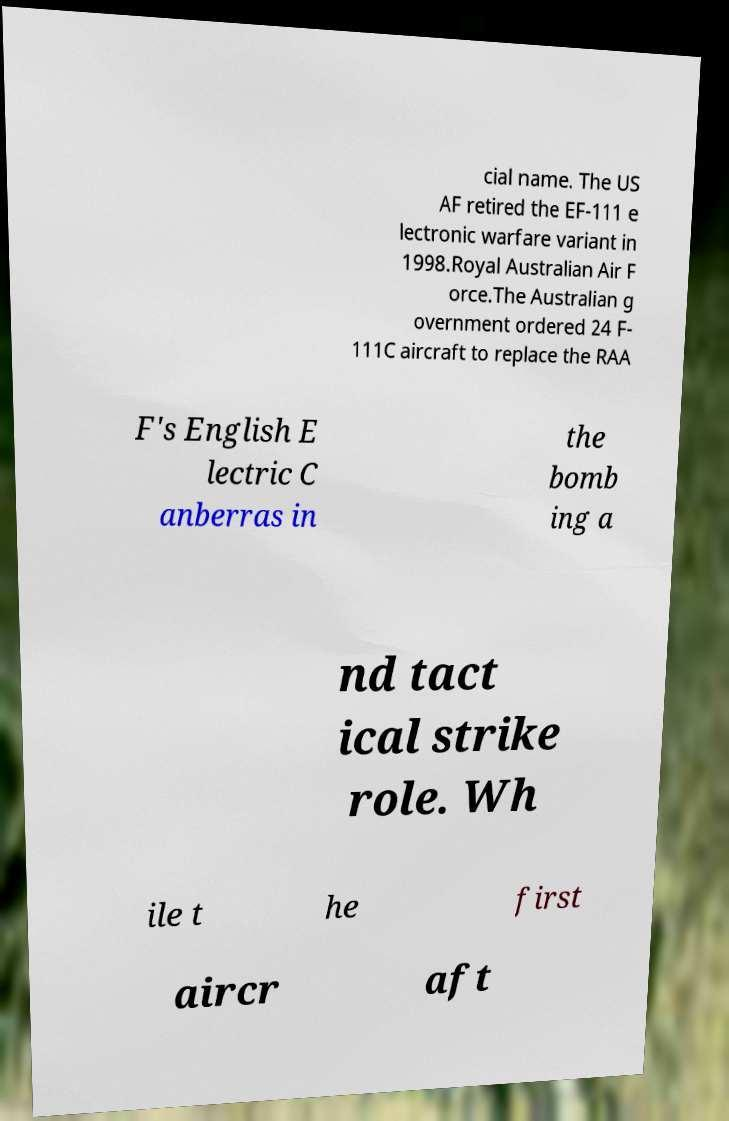There's text embedded in this image that I need extracted. Can you transcribe it verbatim? cial name. The US AF retired the EF-111 e lectronic warfare variant in 1998.Royal Australian Air F orce.The Australian g overnment ordered 24 F- 111C aircraft to replace the RAA F's English E lectric C anberras in the bomb ing a nd tact ical strike role. Wh ile t he first aircr aft 